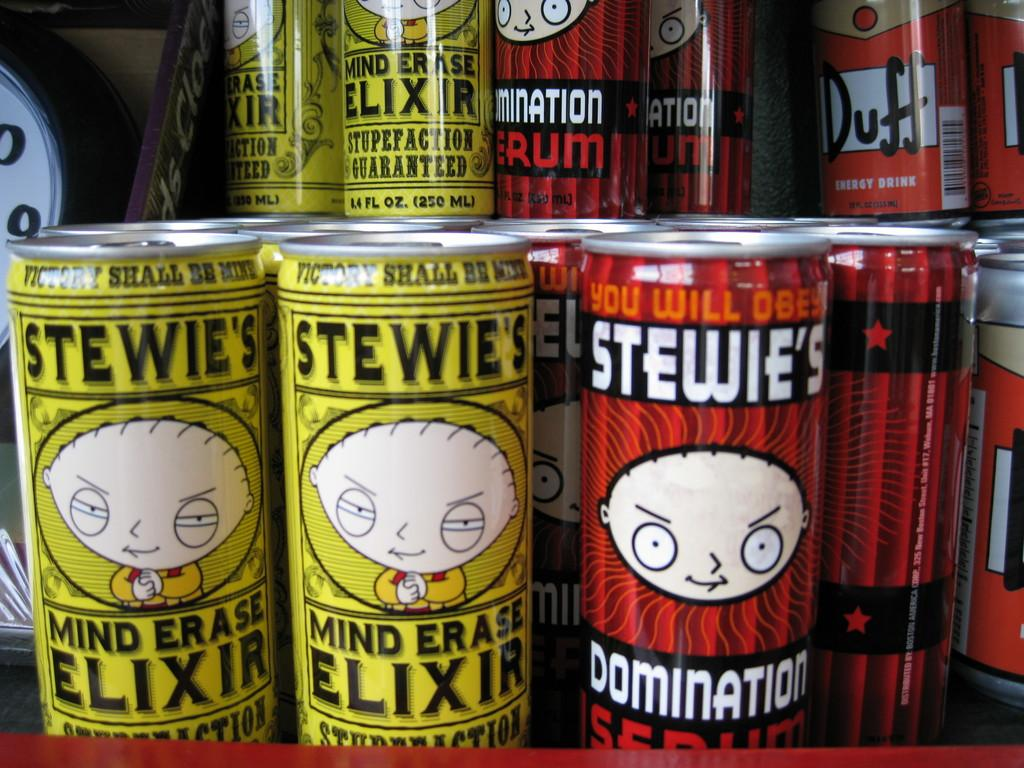<image>
Offer a succinct explanation of the picture presented. Some red and yellow cans with 'Stewie's' written along the top. 